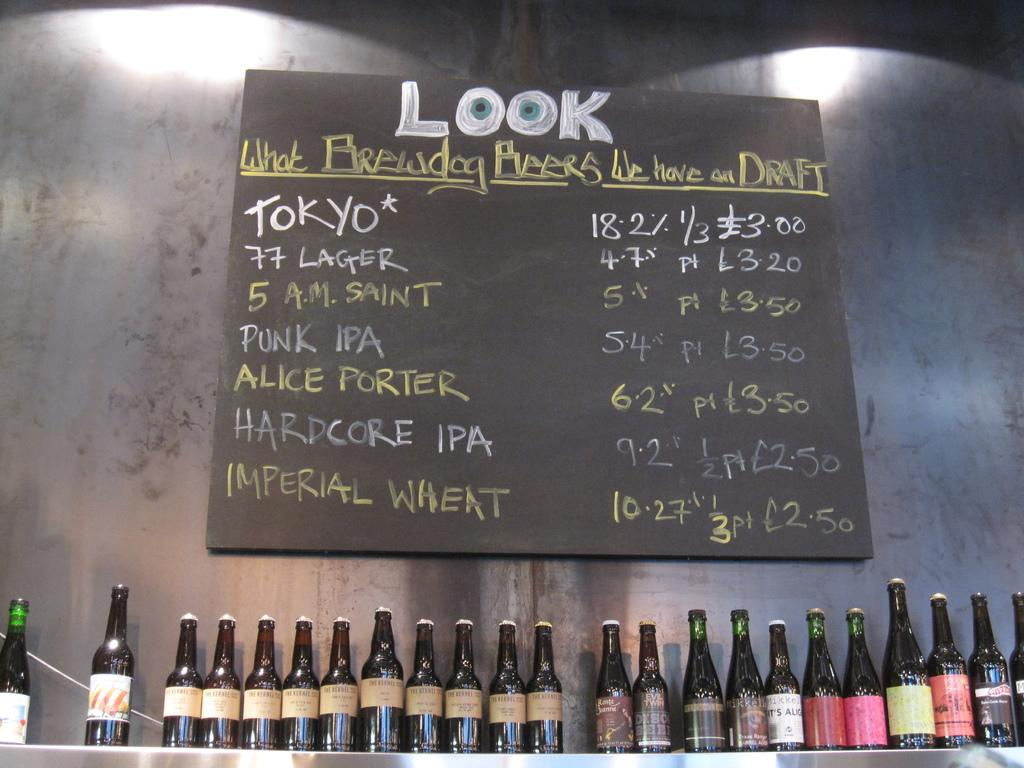<image>
Write a terse but informative summary of the picture. A menu with the word look on it that appears to have eyeballs. 